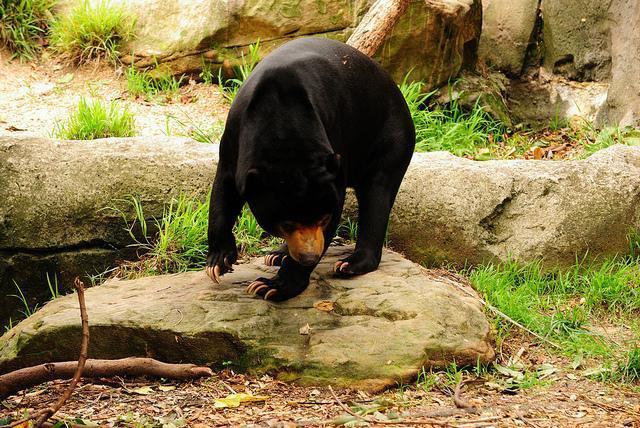How many people are wearing red shirt?
Give a very brief answer. 0. 